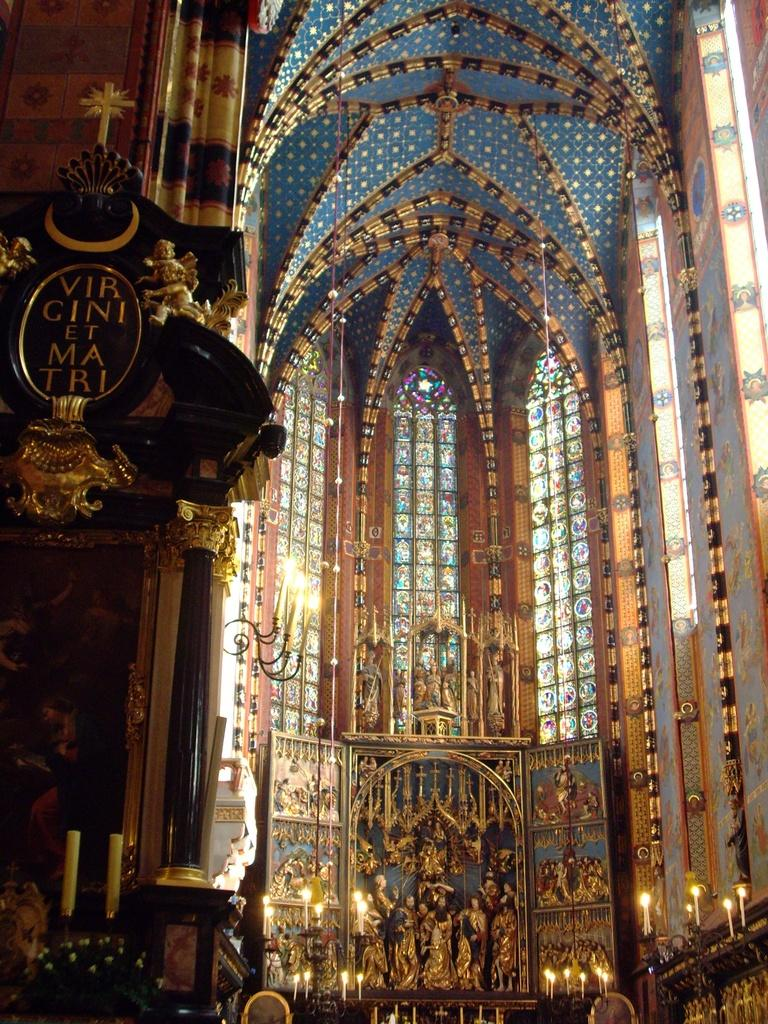What type of building is shown in the image? The image shows an inner view of a building. What specific architectural feature can be seen in the image? There is designer glass in the image. What type of decorative objects are present in the image? There are statues in the image. What decision is being made by the ocean in the image? There is no ocean present in the image, so no decision can be made by it. What title is given to the statues in the image? The provided facts do not mention any titles for the statues in the image. 